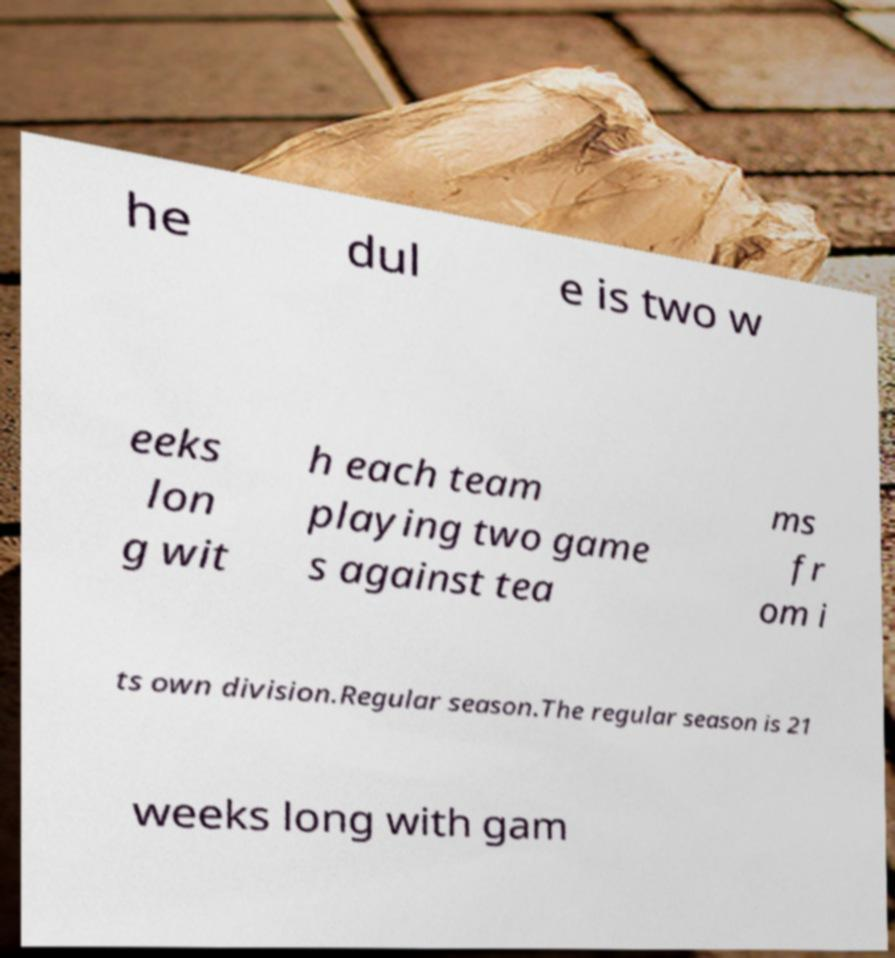Could you assist in decoding the text presented in this image and type it out clearly? he dul e is two w eeks lon g wit h each team playing two game s against tea ms fr om i ts own division.Regular season.The regular season is 21 weeks long with gam 